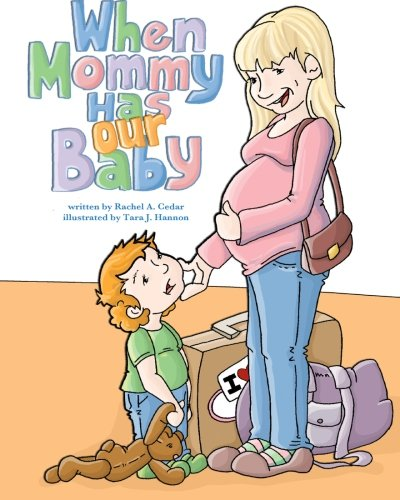Who is the author of this book? The author of the book 'When Mommy Has Our Baby' is Rachel Armstrong Cedar. 